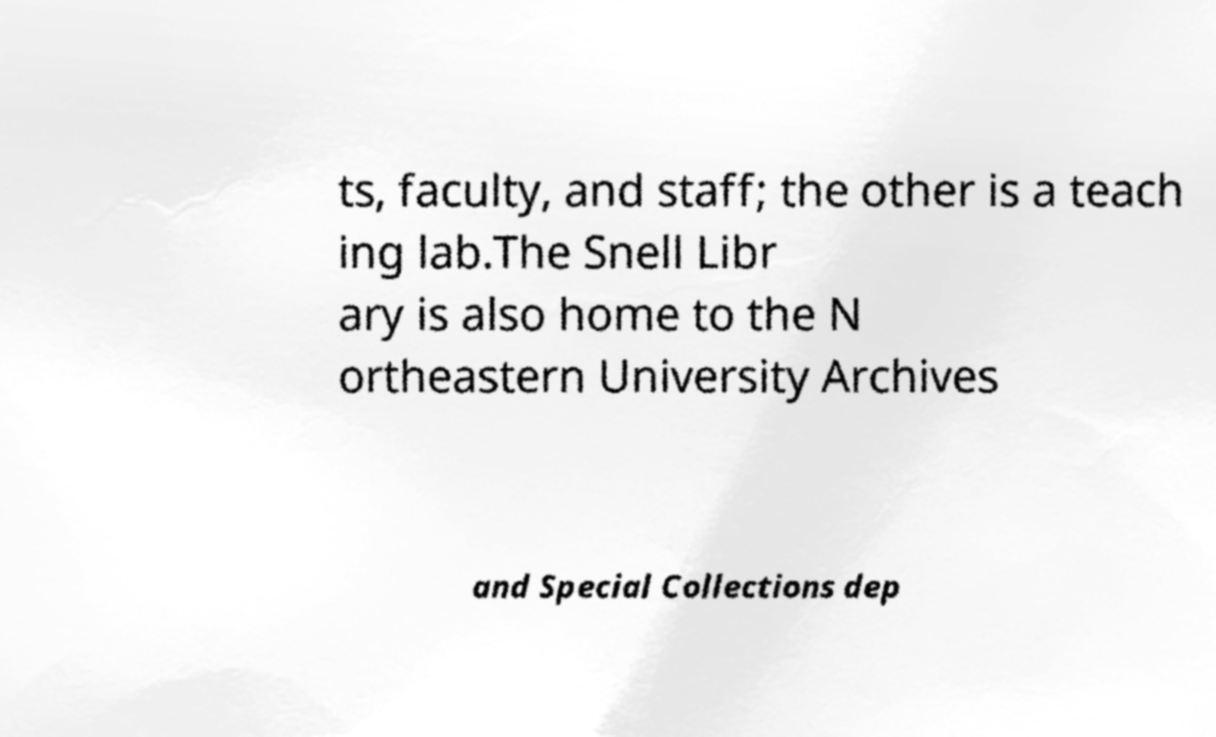Could you assist in decoding the text presented in this image and type it out clearly? ts, faculty, and staff; the other is a teach ing lab.The Snell Libr ary is also home to the N ortheastern University Archives and Special Collections dep 